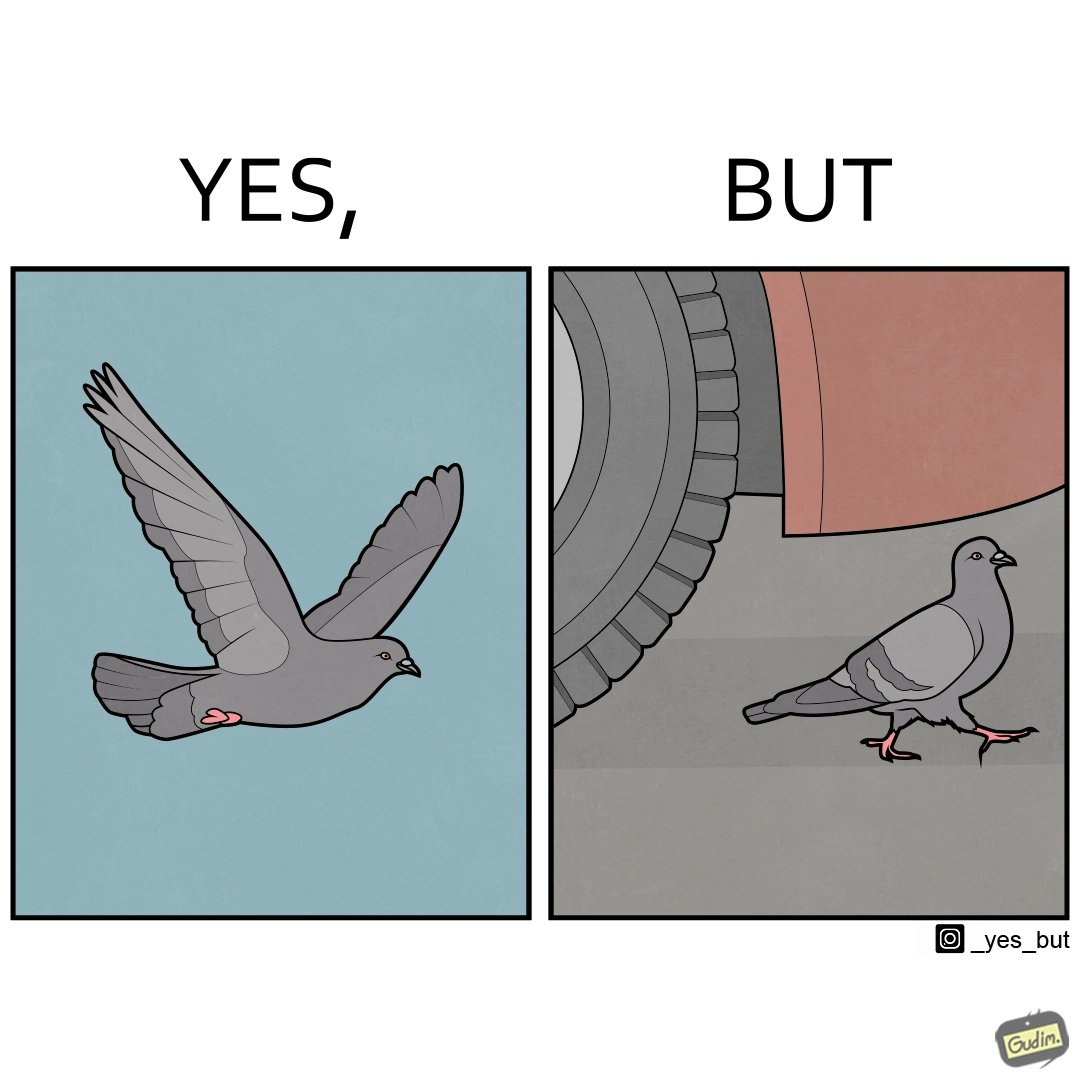Provide a description of this image. The image is ironic, because even when the pigeon has wings to fly it is walking even when it seems threatening to its life 